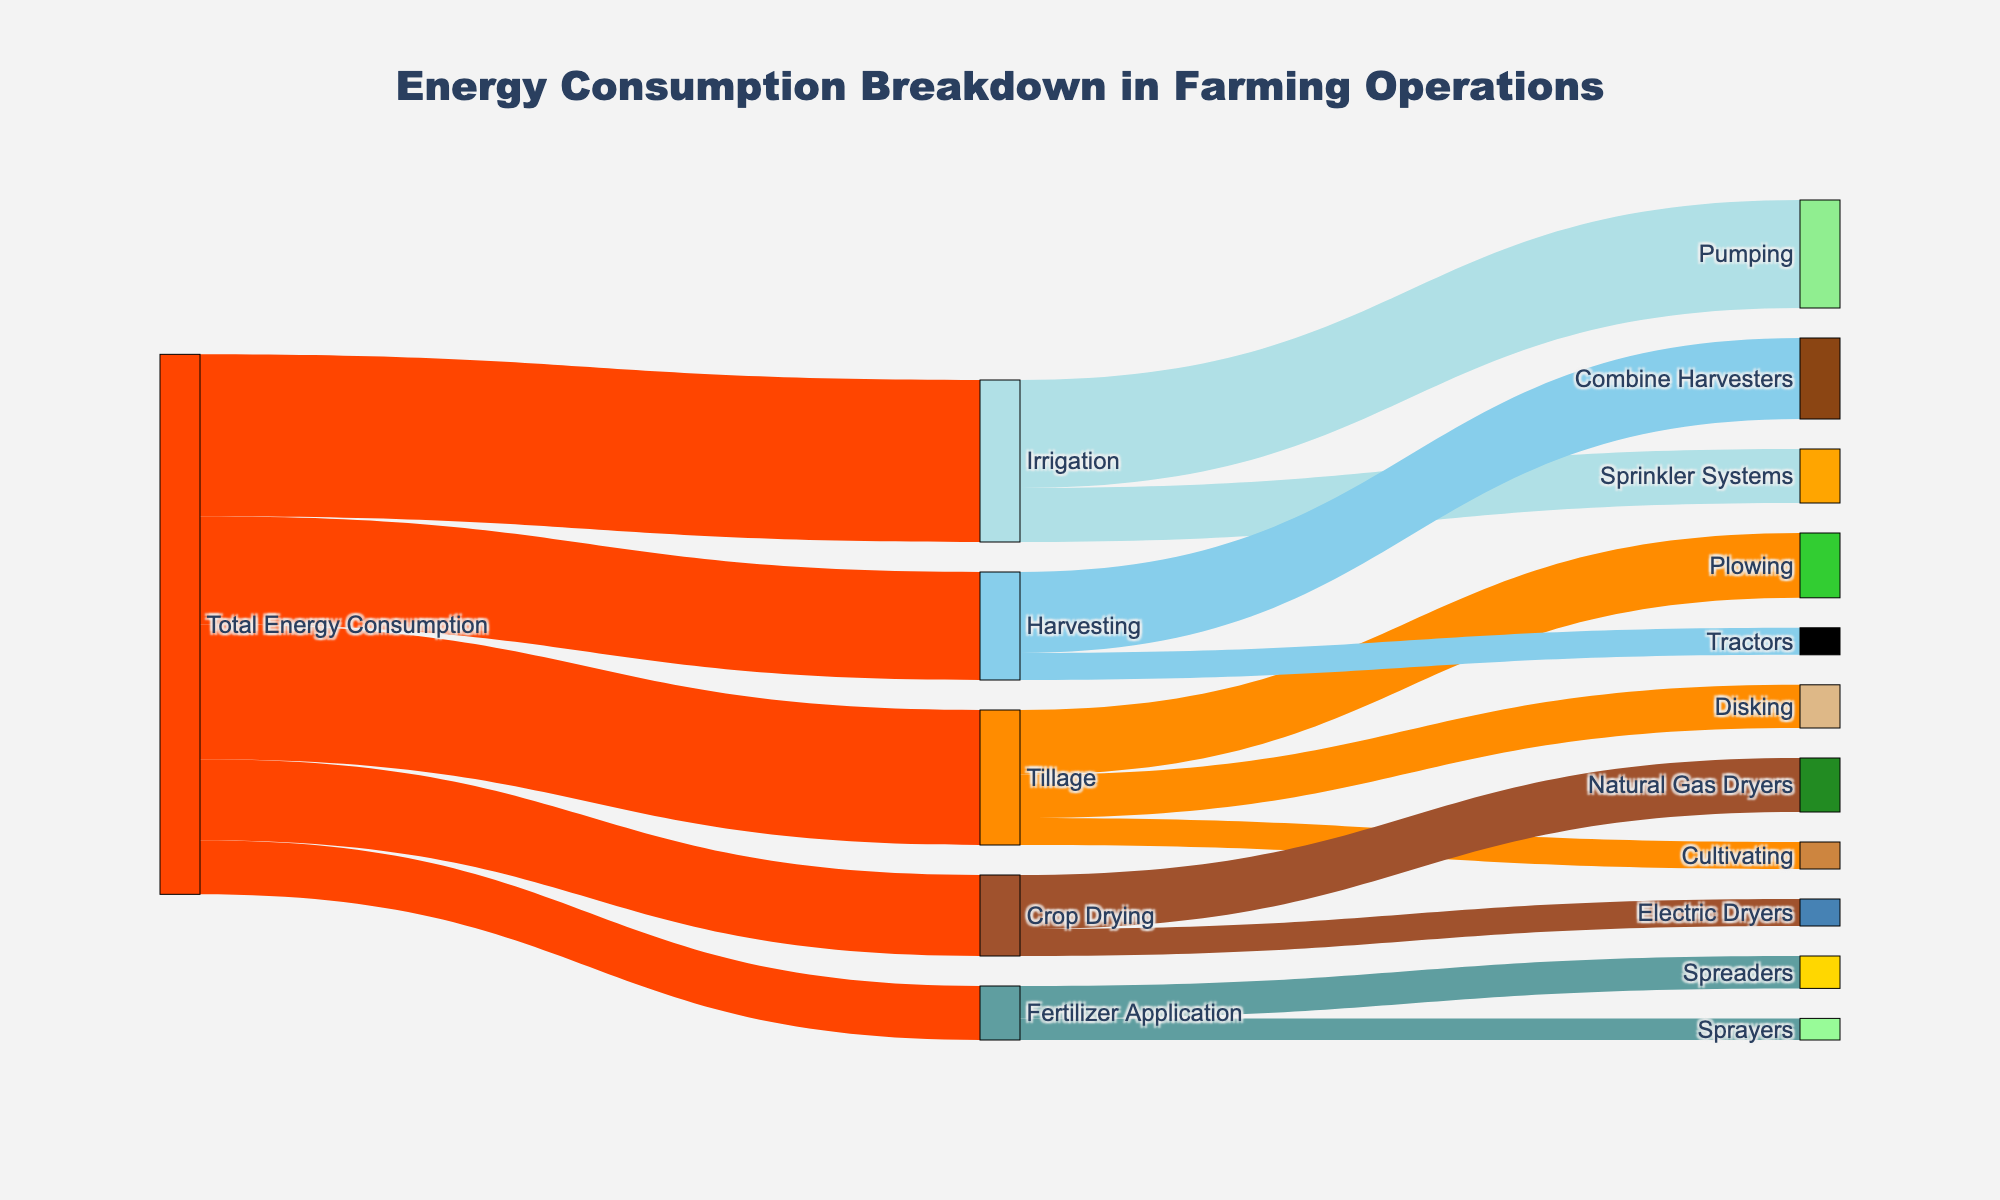How much energy is used for Tillage operations? The Tillage operation is a direct target from Total Energy Consumption. The value connecting "Total Energy Consumption" to "Tillage" is 25.
Answer: 25 Which farming operation consumes the most energy? The farming operation with the highest value connection from "Total Energy Consumption" is "Irrigation" with a value of 30.
Answer: Irrigation How much energy is consumed by all the sub-operations of Crop Drying combined? The sub-operations of Crop Drying are "Natural Gas Dryers" with 10 and "Electric Dryers" with 5. Adding these values: 10 + 5 = 15.
Answer: 15 Which uses more energy: Plowing or Disking? Plowing and Disking are sub-operations of Tillage, with values of 12 and 8 respectively. Since 12 is greater than 8, Plowing uses more energy.
Answer: Plowing What's the total energy consumption of operations involving tractors? The only operation involving tractors is "Harvesting" with "Tractors" consuming 5. Therefore, the total energy consumption is 5.
Answer: 5 What is the sum of energy consumed by Fertilizer Application and its sub-operations? Fertilizer Application from Total Energy Consumption has a value of 10. Its sub-operations are "Spreaders" with 6 and "Sprayers" with 4. Adding these: 10 + 6 + 4 = 20.
Answer: 20 Which sub-operation of Irrigation consumes the least energy? The sub-operations of Irrigation are "Pumping" with 20 and "Sprinkler Systems" with 10. Since 10 is less than 20, Sprinkler Systems consumes the least energy.
Answer: Sprinkler Systems Does Harvesting use more energy than Crop Drying? Harvesting and Crop Drying are direct targets from Total Energy Consumption with values of 20 and 15 respectively. Since 20 is greater than 15, Harvesting uses more energy.
Answer: Harvesting What percentage of the total energy consumption does Fertilizer Application represent? Fertilizer Application consumes 10 out of the total sum of values from Total Energy Consumption: 25 + 30 + 20 + 15 + 10 = 100. The percentage is (10/100) * 100 = 10%.
Answer: 10% What is the difference in energy consumption between Tillage and Irrigation? Tillage consumes 25 and Irrigation consumes 30. The difference is 30 - 25 = 5.
Answer: 5 